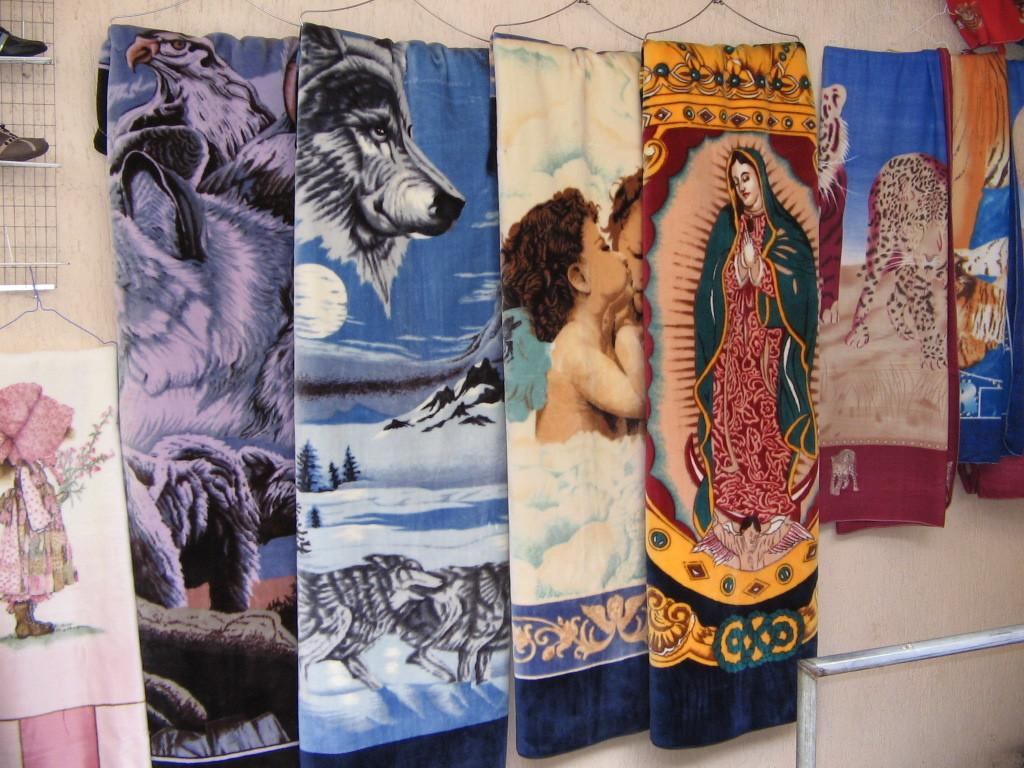What items are present in the image related to warmth or comfort? There are blankets in the image. How do the blankets differ from each other? The blankets have different prints. How are the blankets displayed in the image? The blankets are hanged on a hanger. Where is the hanger located in the image? The hanger is attached to the wall. What type of plastic is used to create the clam in the image? There is no clam present in the image, so it is not possible to determine the type of plastic used. 